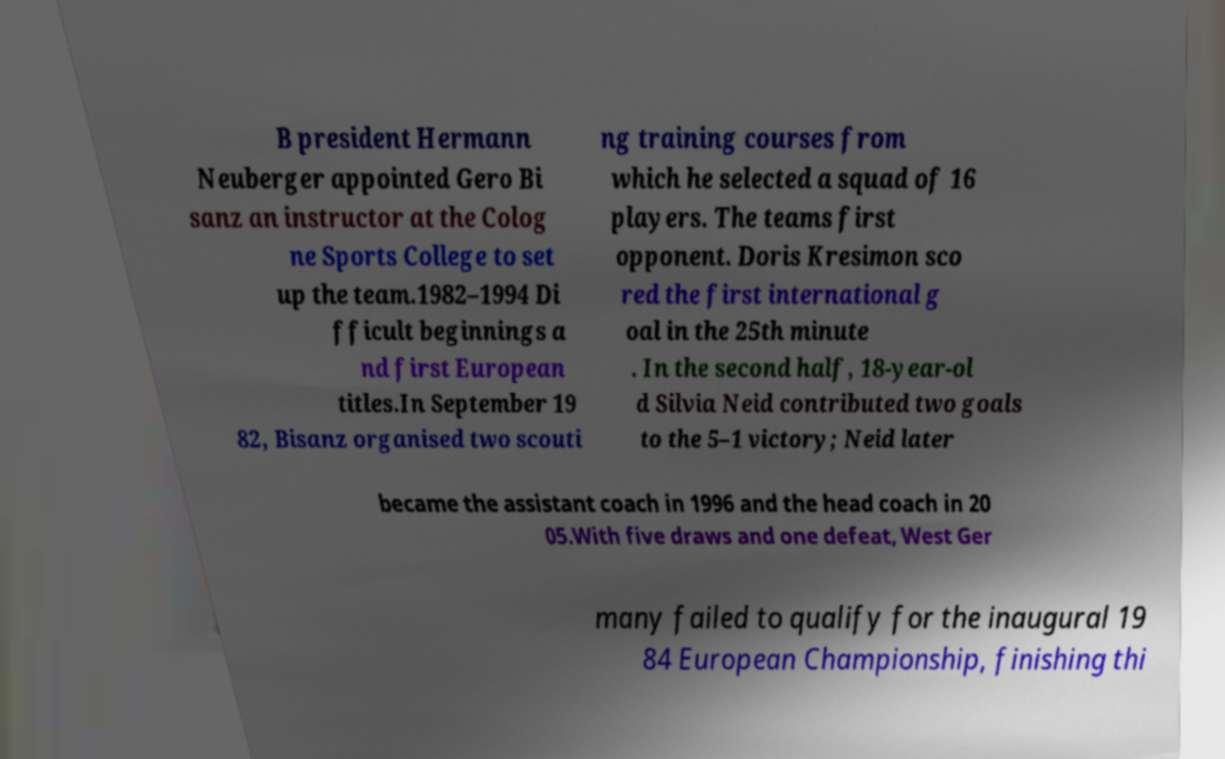Can you read and provide the text displayed in the image?This photo seems to have some interesting text. Can you extract and type it out for me? B president Hermann Neuberger appointed Gero Bi sanz an instructor at the Colog ne Sports College to set up the team.1982–1994 Di fficult beginnings a nd first European titles.In September 19 82, Bisanz organised two scouti ng training courses from which he selected a squad of 16 players. The teams first opponent. Doris Kresimon sco red the first international g oal in the 25th minute . In the second half, 18-year-ol d Silvia Neid contributed two goals to the 5–1 victory; Neid later became the assistant coach in 1996 and the head coach in 20 05.With five draws and one defeat, West Ger many failed to qualify for the inaugural 19 84 European Championship, finishing thi 